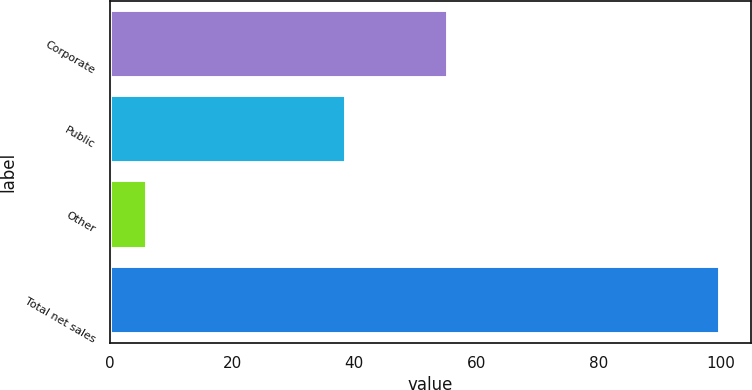Convert chart to OTSL. <chart><loc_0><loc_0><loc_500><loc_500><bar_chart><fcel>Corporate<fcel>Public<fcel>Other<fcel>Total net sales<nl><fcel>55.3<fcel>38.7<fcel>6<fcel>100<nl></chart> 